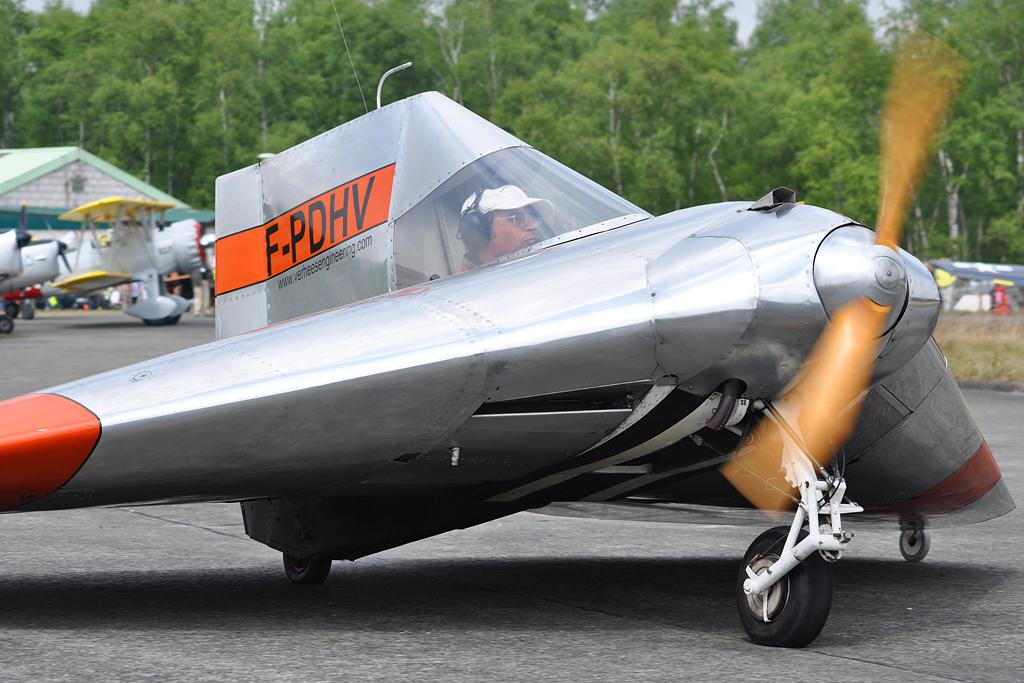Provide a one-sentence caption for the provided image. A plane that is mostly silver with orange wings and orange on the fin with the letters F-PDHV. 